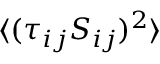Convert formula to latex. <formula><loc_0><loc_0><loc_500><loc_500>{ \langle ( \tau _ { i j } S _ { i j } ) ^ { 2 } \rangle }</formula> 